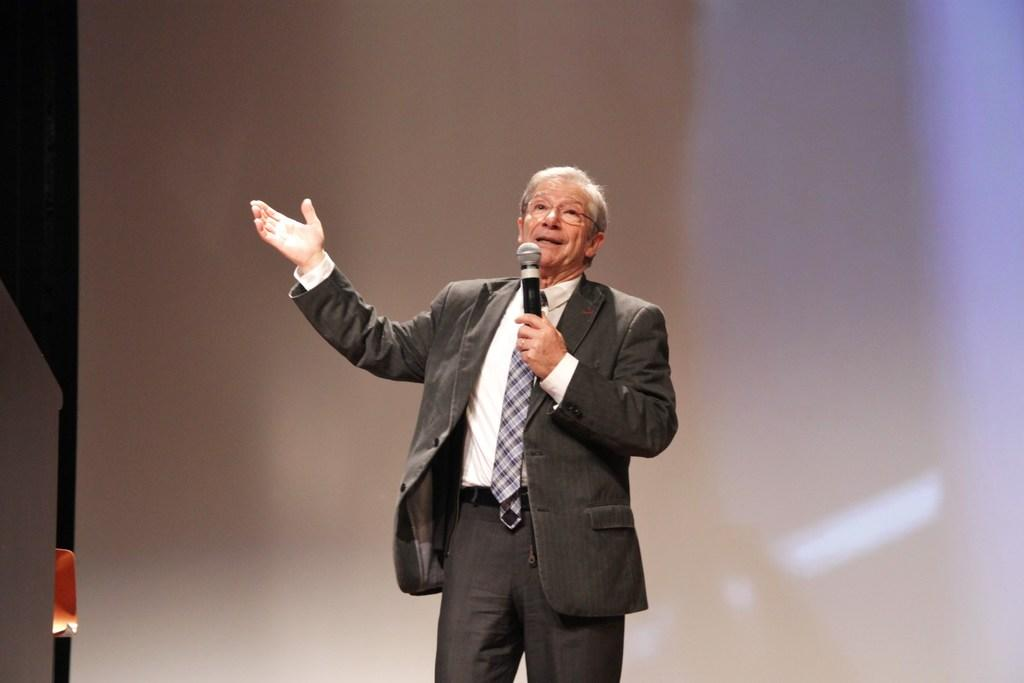What is the person in the image wearing? The person is wearing a suit in the image. What is the person doing in the image? The person is standing and speaking in front of a microphone. What is the color of the background in the image? The background of the image is white in color. How many hands does the cook have in the image? There is no cook present in the image, and therefore no hands to count. Is the horse wearing a saddle in the image? There is no horse present in the image. 